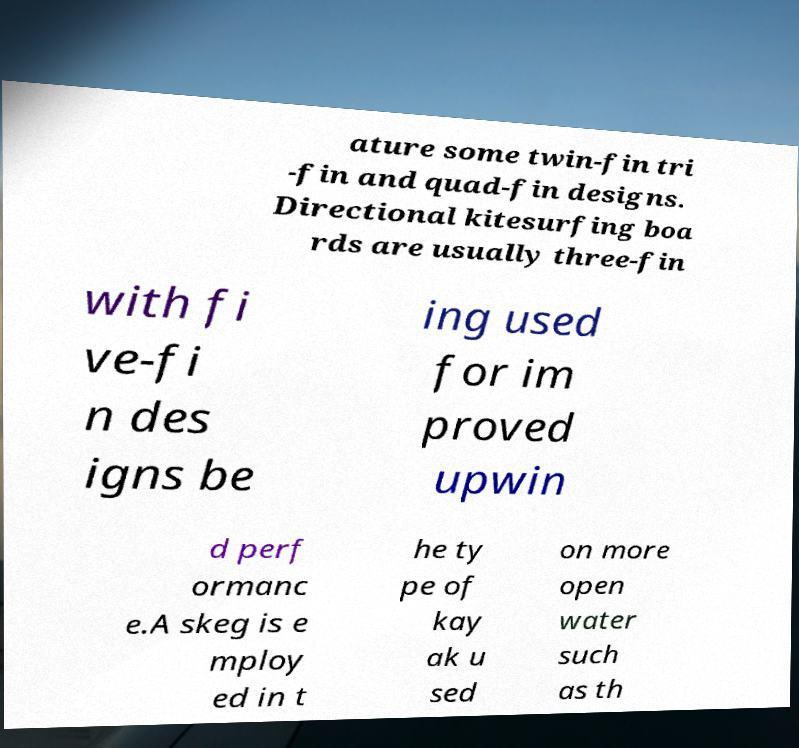Please read and relay the text visible in this image. What does it say? ature some twin-fin tri -fin and quad-fin designs. Directional kitesurfing boa rds are usually three-fin with fi ve-fi n des igns be ing used for im proved upwin d perf ormanc e.A skeg is e mploy ed in t he ty pe of kay ak u sed on more open water such as th 